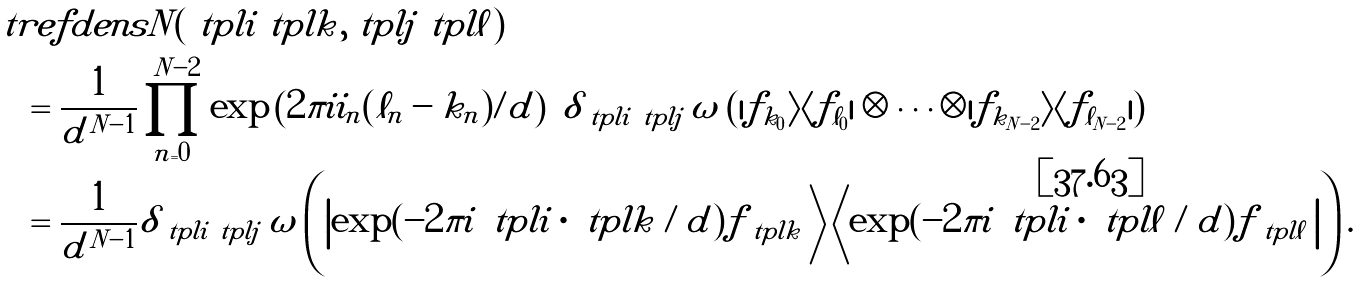Convert formula to latex. <formula><loc_0><loc_0><loc_500><loc_500>& \ t r e f d e n s { N } ( \tilde { \ t p l { i } } \tilde { \ t p l { k } } , \tilde { \ t p l { j } } \tilde { \ t p l { \ell } } ) \\ & \quad = \frac { 1 } { d ^ { N - 1 } } \prod _ { n = 0 } ^ { N - 2 } \exp \left ( 2 \pi i i _ { n } ( \ell _ { n } - k _ { n } ) / d \right ) \ \delta _ { \tilde { \ t p l { i } } \tilde { \ t p l { j } } } \, \omega \left ( | f _ { k _ { 0 } } \rangle \langle f _ { \ell _ { 0 } } | \otimes \cdots \otimes | f _ { k _ { N - 2 } } \rangle \langle f _ { \ell _ { N - 2 } } | \right ) \\ & \quad = \frac { 1 } { d ^ { N - 1 } } \delta _ { \tilde { \ t p l { i } } \tilde { \ t p l { j } } } \, \omega \left ( \left | \exp ( - 2 \pi i \, \tilde { \ t p l { i } } \cdot \tilde { \ t p l { k } } / d ) f _ { \tilde { \ t p l { k } } } \, \right \rangle \left \langle \exp ( - 2 \pi i \, \tilde { \ t p l { i } } \cdot \tilde { \ t p l { \ell } } / d ) f _ { \tilde { \ t p l { \ell } } } \, \right | \right ) .</formula> 